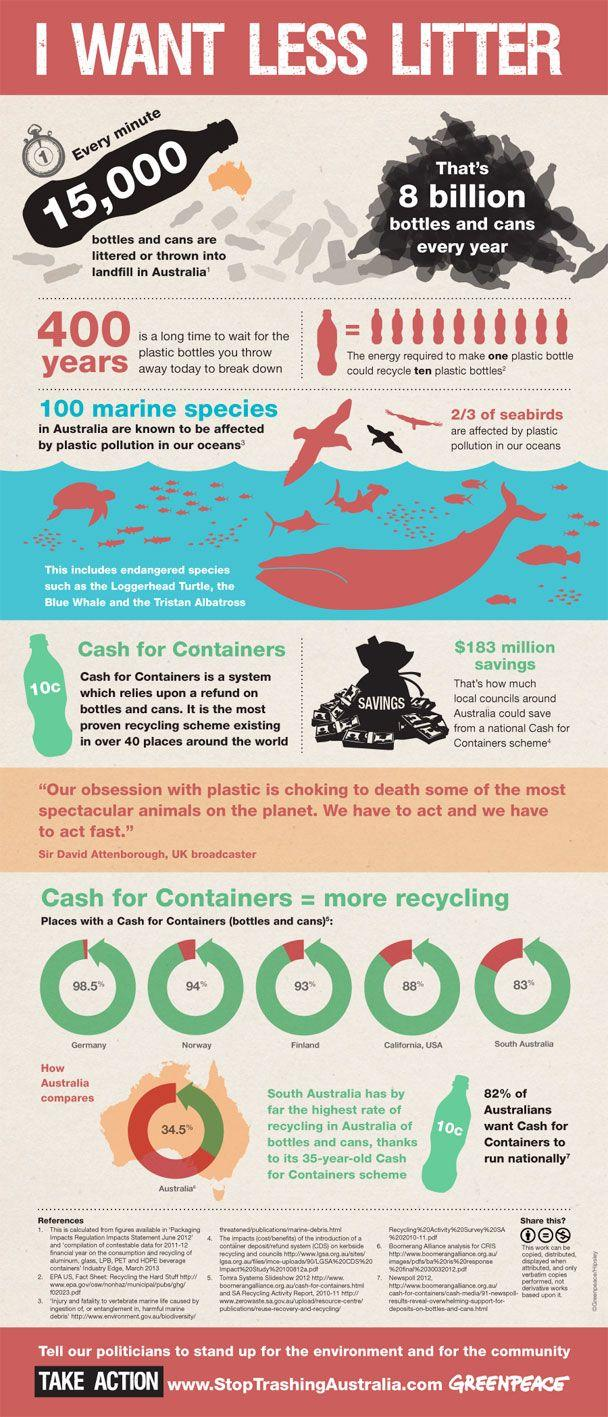Outline some significant characteristics in this image. Out of 3, only 1 seabird is not affected by plastic pollution in our oceans. This infographic contains 5 places that mention cash for containers. Approximately 18% of Australians do not want cash for containers to be implemented nationally. 